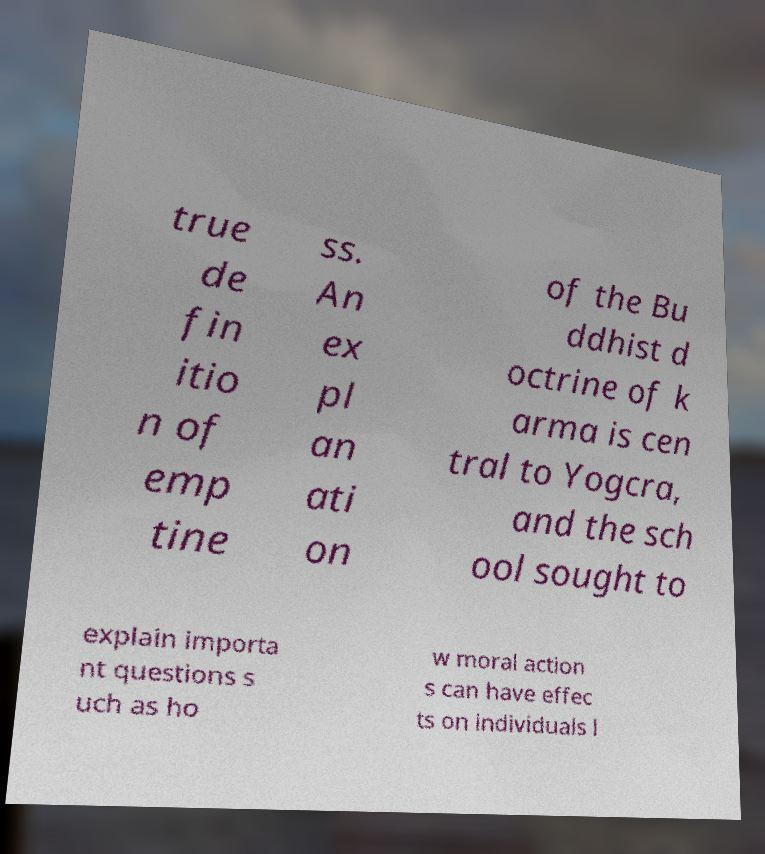I need the written content from this picture converted into text. Can you do that? true de fin itio n of emp tine ss. An ex pl an ati on of the Bu ddhist d octrine of k arma is cen tral to Yogcra, and the sch ool sought to explain importa nt questions s uch as ho w moral action s can have effec ts on individuals l 